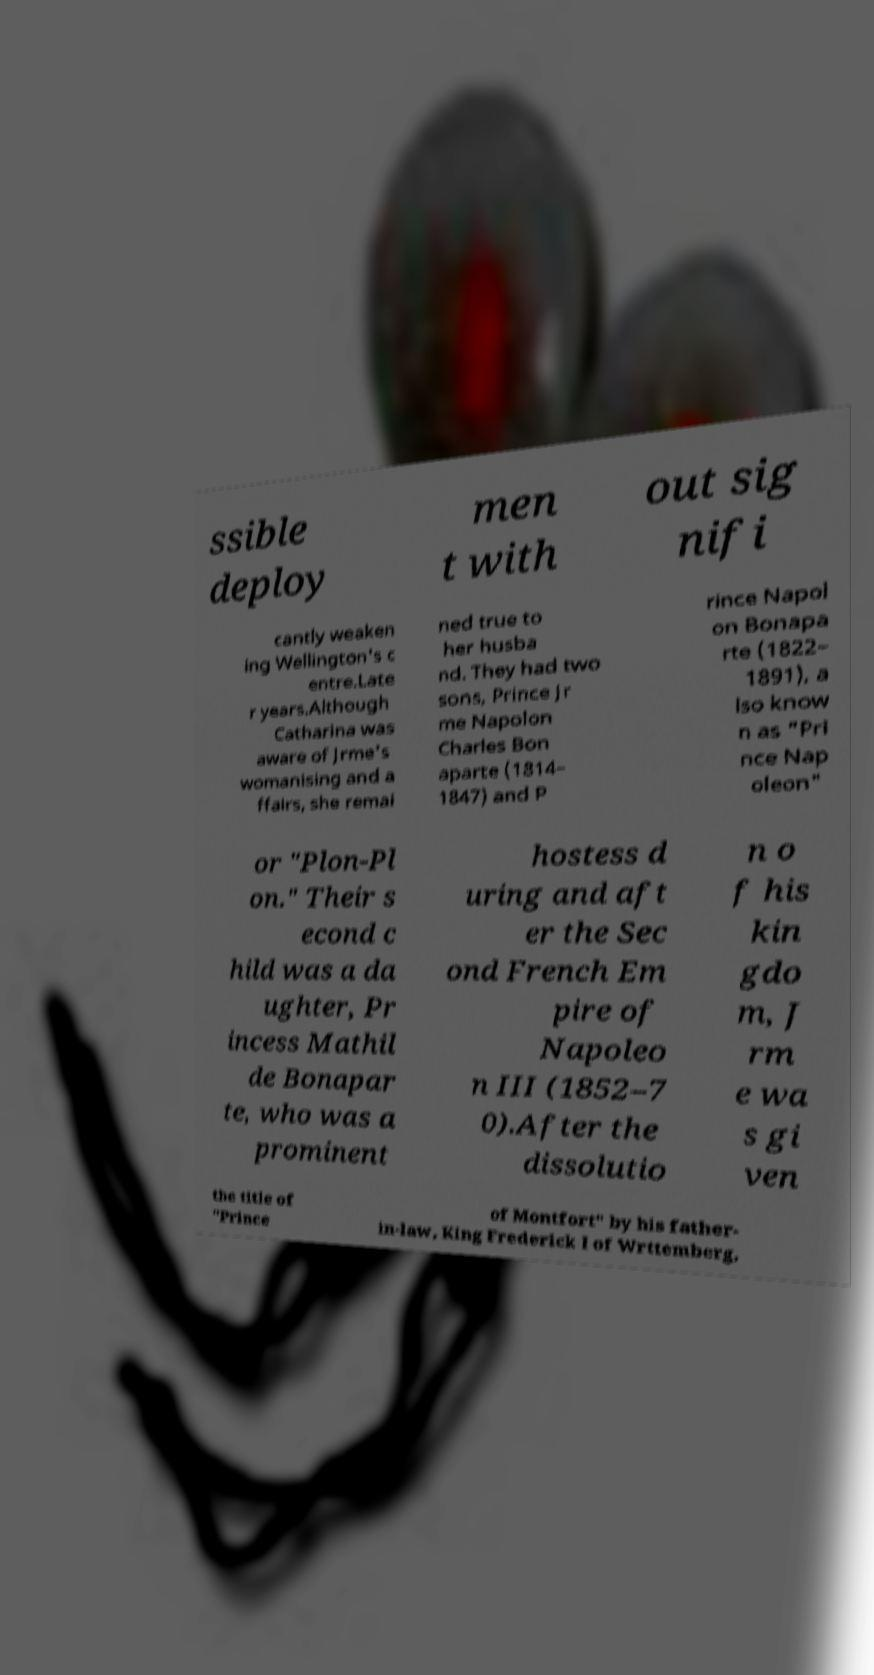There's text embedded in this image that I need extracted. Can you transcribe it verbatim? ssible deploy men t with out sig nifi cantly weaken ing Wellington's c entre.Late r years.Although Catharina was aware of Jrme's womanising and a ffairs, she remai ned true to her husba nd. They had two sons, Prince Jr me Napolon Charles Bon aparte (1814– 1847) and P rince Napol on Bonapa rte (1822– 1891), a lso know n as "Pri nce Nap oleon" or "Plon-Pl on." Their s econd c hild was a da ughter, Pr incess Mathil de Bonapar te, who was a prominent hostess d uring and aft er the Sec ond French Em pire of Napoleo n III (1852–7 0).After the dissolutio n o f his kin gdo m, J rm e wa s gi ven the title of "Prince of Montfort" by his father- in-law, King Frederick I of Wrttemberg, 